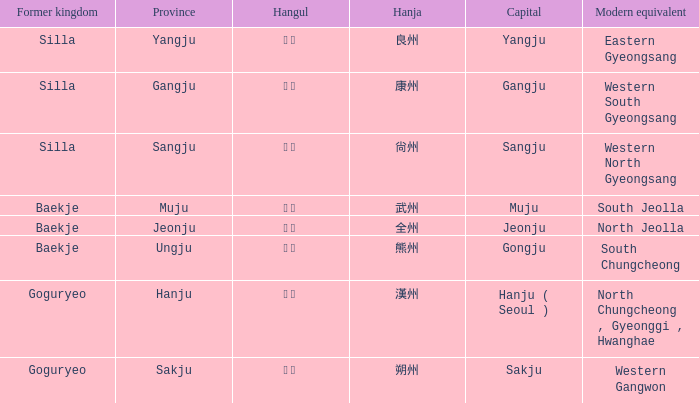How is the province of "sangju" written in hanja? 尙州. 